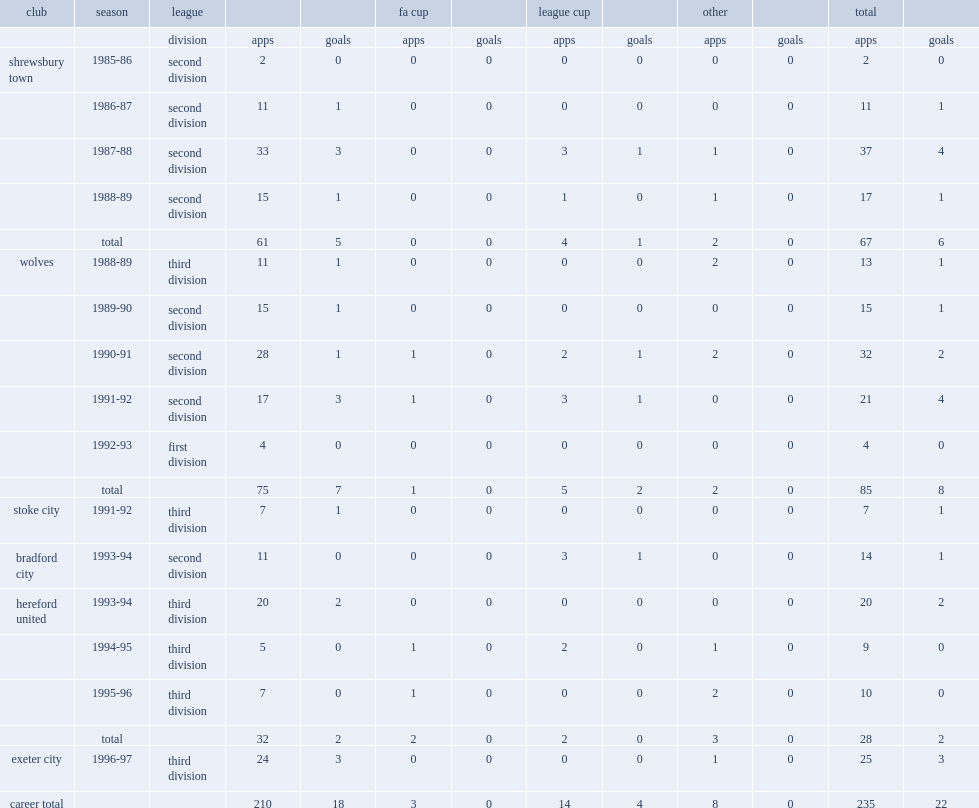Which club did tim steele play for in the third division in 1988-89? Wolves. 